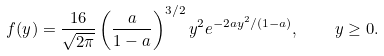<formula> <loc_0><loc_0><loc_500><loc_500>f ( y ) = \frac { 1 6 } { \sqrt { 2 \pi } } \left ( \frac { a } { 1 - a } \right ) ^ { 3 / 2 } y ^ { 2 } e ^ { - 2 a y ^ { 2 } / ( 1 - a ) } , \quad y \geq 0 .</formula> 